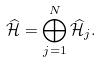<formula> <loc_0><loc_0><loc_500><loc_500>\widehat { \mathcal { H } } = { \mathop \bigoplus _ { j = 1 } ^ { N } } \, \widehat { \mathcal { H } } _ { j } .</formula> 